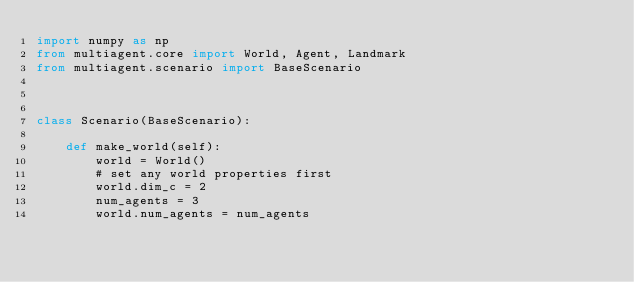Convert code to text. <code><loc_0><loc_0><loc_500><loc_500><_Python_>import numpy as np
from multiagent.core import World, Agent, Landmark
from multiagent.scenario import BaseScenario



class Scenario(BaseScenario):
    
    def make_world(self):
        world = World()
        # set any world properties first
        world.dim_c = 2
        num_agents = 3
        world.num_agents = num_agents</code> 